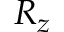<formula> <loc_0><loc_0><loc_500><loc_500>R _ { z }</formula> 